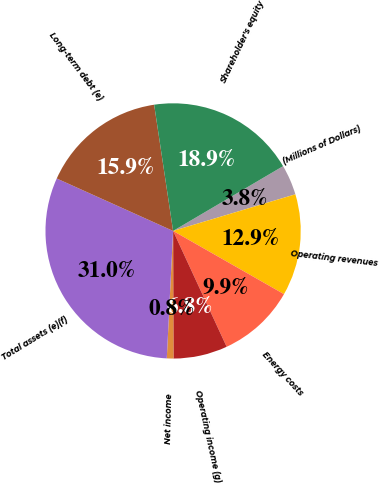Convert chart. <chart><loc_0><loc_0><loc_500><loc_500><pie_chart><fcel>(Millions of Dollars)<fcel>Operating revenues<fcel>Energy costs<fcel>Operating income (g)<fcel>Net income<fcel>Total assets (e)(f)<fcel>Long-term debt (e)<fcel>Shareholder's equity<nl><fcel>3.84%<fcel>12.88%<fcel>9.86%<fcel>6.85%<fcel>0.83%<fcel>30.95%<fcel>15.89%<fcel>18.9%<nl></chart> 